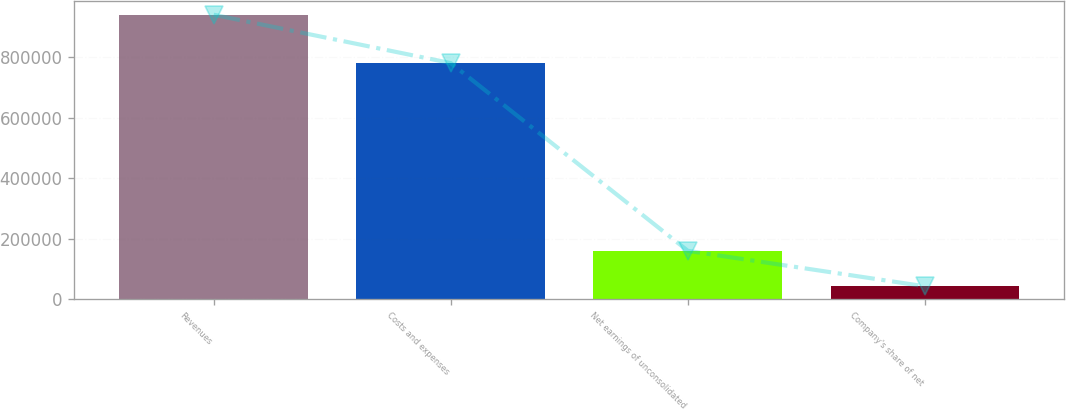Convert chart. <chart><loc_0><loc_0><loc_500><loc_500><bar_chart><fcel>Revenues<fcel>Costs and expenses<fcel>Net earnings of unconsolidated<fcel>Company's share of net<nl><fcel>939847<fcel>780093<fcel>159754<fcel>42651<nl></chart> 